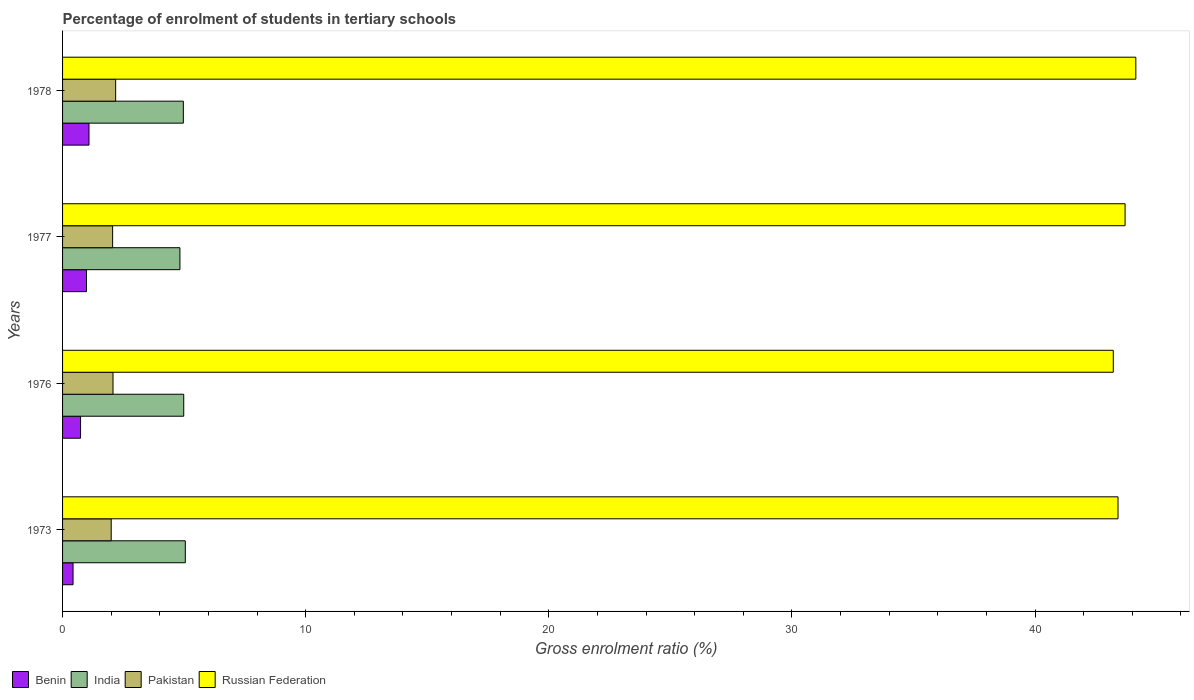How many different coloured bars are there?
Keep it short and to the point. 4. What is the label of the 2nd group of bars from the top?
Your answer should be very brief. 1977. In how many cases, is the number of bars for a given year not equal to the number of legend labels?
Offer a very short reply. 0. What is the percentage of students enrolled in tertiary schools in Russian Federation in 1976?
Give a very brief answer. 43.22. Across all years, what is the maximum percentage of students enrolled in tertiary schools in Benin?
Provide a succinct answer. 1.09. Across all years, what is the minimum percentage of students enrolled in tertiary schools in India?
Offer a very short reply. 4.83. In which year was the percentage of students enrolled in tertiary schools in Russian Federation maximum?
Provide a short and direct response. 1978. What is the total percentage of students enrolled in tertiary schools in India in the graph?
Ensure brevity in your answer.  19.83. What is the difference between the percentage of students enrolled in tertiary schools in Benin in 1973 and that in 1978?
Ensure brevity in your answer.  -0.66. What is the difference between the percentage of students enrolled in tertiary schools in Russian Federation in 1973 and the percentage of students enrolled in tertiary schools in India in 1976?
Provide a succinct answer. 38.43. What is the average percentage of students enrolled in tertiary schools in Pakistan per year?
Provide a short and direct response. 2.08. In the year 1978, what is the difference between the percentage of students enrolled in tertiary schools in Russian Federation and percentage of students enrolled in tertiary schools in Benin?
Keep it short and to the point. 43.06. What is the ratio of the percentage of students enrolled in tertiary schools in India in 1977 to that in 1978?
Provide a succinct answer. 0.97. Is the difference between the percentage of students enrolled in tertiary schools in Russian Federation in 1977 and 1978 greater than the difference between the percentage of students enrolled in tertiary schools in Benin in 1977 and 1978?
Offer a very short reply. No. What is the difference between the highest and the second highest percentage of students enrolled in tertiary schools in Pakistan?
Offer a very short reply. 0.11. What is the difference between the highest and the lowest percentage of students enrolled in tertiary schools in India?
Provide a short and direct response. 0.22. Is the sum of the percentage of students enrolled in tertiary schools in Pakistan in 1973 and 1978 greater than the maximum percentage of students enrolled in tertiary schools in Russian Federation across all years?
Offer a very short reply. No. What does the 2nd bar from the top in 1976 represents?
Offer a very short reply. Pakistan. What does the 1st bar from the bottom in 1973 represents?
Offer a very short reply. Benin. How many bars are there?
Make the answer very short. 16. Are all the bars in the graph horizontal?
Offer a very short reply. Yes. Are the values on the major ticks of X-axis written in scientific E-notation?
Provide a succinct answer. No. How many legend labels are there?
Your response must be concise. 4. What is the title of the graph?
Make the answer very short. Percentage of enrolment of students in tertiary schools. What is the label or title of the Y-axis?
Offer a terse response. Years. What is the Gross enrolment ratio (%) in Benin in 1973?
Provide a succinct answer. 0.43. What is the Gross enrolment ratio (%) in India in 1973?
Make the answer very short. 5.05. What is the Gross enrolment ratio (%) in Pakistan in 1973?
Your answer should be very brief. 2. What is the Gross enrolment ratio (%) of Russian Federation in 1973?
Provide a succinct answer. 43.41. What is the Gross enrolment ratio (%) of Benin in 1976?
Offer a terse response. 0.74. What is the Gross enrolment ratio (%) in India in 1976?
Ensure brevity in your answer.  4.98. What is the Gross enrolment ratio (%) of Pakistan in 1976?
Make the answer very short. 2.08. What is the Gross enrolment ratio (%) in Russian Federation in 1976?
Ensure brevity in your answer.  43.22. What is the Gross enrolment ratio (%) of Benin in 1977?
Offer a very short reply. 0.98. What is the Gross enrolment ratio (%) in India in 1977?
Give a very brief answer. 4.83. What is the Gross enrolment ratio (%) of Pakistan in 1977?
Provide a succinct answer. 2.06. What is the Gross enrolment ratio (%) of Russian Federation in 1977?
Give a very brief answer. 43.7. What is the Gross enrolment ratio (%) of Benin in 1978?
Give a very brief answer. 1.09. What is the Gross enrolment ratio (%) in India in 1978?
Give a very brief answer. 4.97. What is the Gross enrolment ratio (%) in Pakistan in 1978?
Your answer should be very brief. 2.18. What is the Gross enrolment ratio (%) in Russian Federation in 1978?
Offer a terse response. 44.15. Across all years, what is the maximum Gross enrolment ratio (%) of Benin?
Keep it short and to the point. 1.09. Across all years, what is the maximum Gross enrolment ratio (%) in India?
Provide a succinct answer. 5.05. Across all years, what is the maximum Gross enrolment ratio (%) of Pakistan?
Your answer should be very brief. 2.18. Across all years, what is the maximum Gross enrolment ratio (%) in Russian Federation?
Provide a succinct answer. 44.15. Across all years, what is the minimum Gross enrolment ratio (%) of Benin?
Provide a succinct answer. 0.43. Across all years, what is the minimum Gross enrolment ratio (%) of India?
Offer a very short reply. 4.83. Across all years, what is the minimum Gross enrolment ratio (%) in Pakistan?
Make the answer very short. 2. Across all years, what is the minimum Gross enrolment ratio (%) in Russian Federation?
Your answer should be compact. 43.22. What is the total Gross enrolment ratio (%) in Benin in the graph?
Offer a terse response. 3.24. What is the total Gross enrolment ratio (%) of India in the graph?
Ensure brevity in your answer.  19.83. What is the total Gross enrolment ratio (%) of Pakistan in the graph?
Your answer should be very brief. 8.32. What is the total Gross enrolment ratio (%) in Russian Federation in the graph?
Keep it short and to the point. 174.48. What is the difference between the Gross enrolment ratio (%) in Benin in 1973 and that in 1976?
Provide a short and direct response. -0.31. What is the difference between the Gross enrolment ratio (%) in India in 1973 and that in 1976?
Your answer should be very brief. 0.06. What is the difference between the Gross enrolment ratio (%) of Pakistan in 1973 and that in 1976?
Provide a succinct answer. -0.07. What is the difference between the Gross enrolment ratio (%) of Russian Federation in 1973 and that in 1976?
Your answer should be very brief. 0.19. What is the difference between the Gross enrolment ratio (%) of Benin in 1973 and that in 1977?
Your answer should be very brief. -0.55. What is the difference between the Gross enrolment ratio (%) of India in 1973 and that in 1977?
Offer a terse response. 0.22. What is the difference between the Gross enrolment ratio (%) in Pakistan in 1973 and that in 1977?
Your answer should be compact. -0.06. What is the difference between the Gross enrolment ratio (%) in Russian Federation in 1973 and that in 1977?
Keep it short and to the point. -0.29. What is the difference between the Gross enrolment ratio (%) of Benin in 1973 and that in 1978?
Your answer should be very brief. -0.66. What is the difference between the Gross enrolment ratio (%) in India in 1973 and that in 1978?
Provide a short and direct response. 0.08. What is the difference between the Gross enrolment ratio (%) in Pakistan in 1973 and that in 1978?
Offer a terse response. -0.18. What is the difference between the Gross enrolment ratio (%) of Russian Federation in 1973 and that in 1978?
Offer a very short reply. -0.73. What is the difference between the Gross enrolment ratio (%) in Benin in 1976 and that in 1977?
Make the answer very short. -0.24. What is the difference between the Gross enrolment ratio (%) in India in 1976 and that in 1977?
Your answer should be compact. 0.16. What is the difference between the Gross enrolment ratio (%) in Pakistan in 1976 and that in 1977?
Give a very brief answer. 0.02. What is the difference between the Gross enrolment ratio (%) of Russian Federation in 1976 and that in 1977?
Your answer should be compact. -0.49. What is the difference between the Gross enrolment ratio (%) in Benin in 1976 and that in 1978?
Offer a very short reply. -0.35. What is the difference between the Gross enrolment ratio (%) of India in 1976 and that in 1978?
Provide a succinct answer. 0.02. What is the difference between the Gross enrolment ratio (%) of Pakistan in 1976 and that in 1978?
Give a very brief answer. -0.11. What is the difference between the Gross enrolment ratio (%) in Russian Federation in 1976 and that in 1978?
Give a very brief answer. -0.93. What is the difference between the Gross enrolment ratio (%) of Benin in 1977 and that in 1978?
Provide a short and direct response. -0.1. What is the difference between the Gross enrolment ratio (%) in India in 1977 and that in 1978?
Your answer should be very brief. -0.14. What is the difference between the Gross enrolment ratio (%) in Pakistan in 1977 and that in 1978?
Your answer should be compact. -0.12. What is the difference between the Gross enrolment ratio (%) in Russian Federation in 1977 and that in 1978?
Provide a short and direct response. -0.44. What is the difference between the Gross enrolment ratio (%) in Benin in 1973 and the Gross enrolment ratio (%) in India in 1976?
Your answer should be very brief. -4.55. What is the difference between the Gross enrolment ratio (%) of Benin in 1973 and the Gross enrolment ratio (%) of Pakistan in 1976?
Your answer should be compact. -1.64. What is the difference between the Gross enrolment ratio (%) in Benin in 1973 and the Gross enrolment ratio (%) in Russian Federation in 1976?
Offer a terse response. -42.79. What is the difference between the Gross enrolment ratio (%) in India in 1973 and the Gross enrolment ratio (%) in Pakistan in 1976?
Provide a succinct answer. 2.97. What is the difference between the Gross enrolment ratio (%) in India in 1973 and the Gross enrolment ratio (%) in Russian Federation in 1976?
Your answer should be compact. -38.17. What is the difference between the Gross enrolment ratio (%) in Pakistan in 1973 and the Gross enrolment ratio (%) in Russian Federation in 1976?
Your answer should be compact. -41.22. What is the difference between the Gross enrolment ratio (%) in Benin in 1973 and the Gross enrolment ratio (%) in India in 1977?
Offer a terse response. -4.4. What is the difference between the Gross enrolment ratio (%) in Benin in 1973 and the Gross enrolment ratio (%) in Pakistan in 1977?
Your answer should be compact. -1.63. What is the difference between the Gross enrolment ratio (%) of Benin in 1973 and the Gross enrolment ratio (%) of Russian Federation in 1977?
Offer a terse response. -43.27. What is the difference between the Gross enrolment ratio (%) of India in 1973 and the Gross enrolment ratio (%) of Pakistan in 1977?
Provide a short and direct response. 2.99. What is the difference between the Gross enrolment ratio (%) of India in 1973 and the Gross enrolment ratio (%) of Russian Federation in 1977?
Provide a succinct answer. -38.65. What is the difference between the Gross enrolment ratio (%) of Pakistan in 1973 and the Gross enrolment ratio (%) of Russian Federation in 1977?
Keep it short and to the point. -41.7. What is the difference between the Gross enrolment ratio (%) of Benin in 1973 and the Gross enrolment ratio (%) of India in 1978?
Your response must be concise. -4.54. What is the difference between the Gross enrolment ratio (%) in Benin in 1973 and the Gross enrolment ratio (%) in Pakistan in 1978?
Keep it short and to the point. -1.75. What is the difference between the Gross enrolment ratio (%) of Benin in 1973 and the Gross enrolment ratio (%) of Russian Federation in 1978?
Make the answer very short. -43.71. What is the difference between the Gross enrolment ratio (%) in India in 1973 and the Gross enrolment ratio (%) in Pakistan in 1978?
Your answer should be very brief. 2.87. What is the difference between the Gross enrolment ratio (%) in India in 1973 and the Gross enrolment ratio (%) in Russian Federation in 1978?
Give a very brief answer. -39.1. What is the difference between the Gross enrolment ratio (%) in Pakistan in 1973 and the Gross enrolment ratio (%) in Russian Federation in 1978?
Offer a terse response. -42.14. What is the difference between the Gross enrolment ratio (%) of Benin in 1976 and the Gross enrolment ratio (%) of India in 1977?
Give a very brief answer. -4.09. What is the difference between the Gross enrolment ratio (%) of Benin in 1976 and the Gross enrolment ratio (%) of Pakistan in 1977?
Give a very brief answer. -1.32. What is the difference between the Gross enrolment ratio (%) in Benin in 1976 and the Gross enrolment ratio (%) in Russian Federation in 1977?
Give a very brief answer. -42.96. What is the difference between the Gross enrolment ratio (%) of India in 1976 and the Gross enrolment ratio (%) of Pakistan in 1977?
Give a very brief answer. 2.93. What is the difference between the Gross enrolment ratio (%) of India in 1976 and the Gross enrolment ratio (%) of Russian Federation in 1977?
Your answer should be compact. -38.72. What is the difference between the Gross enrolment ratio (%) of Pakistan in 1976 and the Gross enrolment ratio (%) of Russian Federation in 1977?
Make the answer very short. -41.63. What is the difference between the Gross enrolment ratio (%) of Benin in 1976 and the Gross enrolment ratio (%) of India in 1978?
Your response must be concise. -4.23. What is the difference between the Gross enrolment ratio (%) of Benin in 1976 and the Gross enrolment ratio (%) of Pakistan in 1978?
Provide a short and direct response. -1.44. What is the difference between the Gross enrolment ratio (%) in Benin in 1976 and the Gross enrolment ratio (%) in Russian Federation in 1978?
Ensure brevity in your answer.  -43.41. What is the difference between the Gross enrolment ratio (%) in India in 1976 and the Gross enrolment ratio (%) in Pakistan in 1978?
Make the answer very short. 2.8. What is the difference between the Gross enrolment ratio (%) in India in 1976 and the Gross enrolment ratio (%) in Russian Federation in 1978?
Your answer should be very brief. -39.16. What is the difference between the Gross enrolment ratio (%) of Pakistan in 1976 and the Gross enrolment ratio (%) of Russian Federation in 1978?
Your answer should be very brief. -42.07. What is the difference between the Gross enrolment ratio (%) in Benin in 1977 and the Gross enrolment ratio (%) in India in 1978?
Offer a very short reply. -3.98. What is the difference between the Gross enrolment ratio (%) of Benin in 1977 and the Gross enrolment ratio (%) of Pakistan in 1978?
Ensure brevity in your answer.  -1.2. What is the difference between the Gross enrolment ratio (%) in Benin in 1977 and the Gross enrolment ratio (%) in Russian Federation in 1978?
Keep it short and to the point. -43.16. What is the difference between the Gross enrolment ratio (%) in India in 1977 and the Gross enrolment ratio (%) in Pakistan in 1978?
Give a very brief answer. 2.64. What is the difference between the Gross enrolment ratio (%) in India in 1977 and the Gross enrolment ratio (%) in Russian Federation in 1978?
Provide a short and direct response. -39.32. What is the difference between the Gross enrolment ratio (%) in Pakistan in 1977 and the Gross enrolment ratio (%) in Russian Federation in 1978?
Your answer should be compact. -42.09. What is the average Gross enrolment ratio (%) of Benin per year?
Offer a very short reply. 0.81. What is the average Gross enrolment ratio (%) in India per year?
Your answer should be compact. 4.96. What is the average Gross enrolment ratio (%) in Pakistan per year?
Your response must be concise. 2.08. What is the average Gross enrolment ratio (%) in Russian Federation per year?
Ensure brevity in your answer.  43.62. In the year 1973, what is the difference between the Gross enrolment ratio (%) of Benin and Gross enrolment ratio (%) of India?
Your answer should be very brief. -4.62. In the year 1973, what is the difference between the Gross enrolment ratio (%) in Benin and Gross enrolment ratio (%) in Pakistan?
Provide a short and direct response. -1.57. In the year 1973, what is the difference between the Gross enrolment ratio (%) in Benin and Gross enrolment ratio (%) in Russian Federation?
Your answer should be very brief. -42.98. In the year 1973, what is the difference between the Gross enrolment ratio (%) in India and Gross enrolment ratio (%) in Pakistan?
Keep it short and to the point. 3.05. In the year 1973, what is the difference between the Gross enrolment ratio (%) in India and Gross enrolment ratio (%) in Russian Federation?
Provide a short and direct response. -38.36. In the year 1973, what is the difference between the Gross enrolment ratio (%) in Pakistan and Gross enrolment ratio (%) in Russian Federation?
Ensure brevity in your answer.  -41.41. In the year 1976, what is the difference between the Gross enrolment ratio (%) in Benin and Gross enrolment ratio (%) in India?
Offer a terse response. -4.24. In the year 1976, what is the difference between the Gross enrolment ratio (%) in Benin and Gross enrolment ratio (%) in Pakistan?
Your answer should be very brief. -1.34. In the year 1976, what is the difference between the Gross enrolment ratio (%) of Benin and Gross enrolment ratio (%) of Russian Federation?
Your response must be concise. -42.48. In the year 1976, what is the difference between the Gross enrolment ratio (%) in India and Gross enrolment ratio (%) in Pakistan?
Your answer should be very brief. 2.91. In the year 1976, what is the difference between the Gross enrolment ratio (%) of India and Gross enrolment ratio (%) of Russian Federation?
Your answer should be very brief. -38.23. In the year 1976, what is the difference between the Gross enrolment ratio (%) of Pakistan and Gross enrolment ratio (%) of Russian Federation?
Give a very brief answer. -41.14. In the year 1977, what is the difference between the Gross enrolment ratio (%) in Benin and Gross enrolment ratio (%) in India?
Give a very brief answer. -3.84. In the year 1977, what is the difference between the Gross enrolment ratio (%) in Benin and Gross enrolment ratio (%) in Pakistan?
Your answer should be compact. -1.08. In the year 1977, what is the difference between the Gross enrolment ratio (%) in Benin and Gross enrolment ratio (%) in Russian Federation?
Provide a short and direct response. -42.72. In the year 1977, what is the difference between the Gross enrolment ratio (%) of India and Gross enrolment ratio (%) of Pakistan?
Your answer should be compact. 2.77. In the year 1977, what is the difference between the Gross enrolment ratio (%) in India and Gross enrolment ratio (%) in Russian Federation?
Provide a succinct answer. -38.88. In the year 1977, what is the difference between the Gross enrolment ratio (%) in Pakistan and Gross enrolment ratio (%) in Russian Federation?
Your response must be concise. -41.64. In the year 1978, what is the difference between the Gross enrolment ratio (%) in Benin and Gross enrolment ratio (%) in India?
Offer a terse response. -3.88. In the year 1978, what is the difference between the Gross enrolment ratio (%) of Benin and Gross enrolment ratio (%) of Pakistan?
Provide a succinct answer. -1.1. In the year 1978, what is the difference between the Gross enrolment ratio (%) in Benin and Gross enrolment ratio (%) in Russian Federation?
Offer a terse response. -43.06. In the year 1978, what is the difference between the Gross enrolment ratio (%) of India and Gross enrolment ratio (%) of Pakistan?
Make the answer very short. 2.78. In the year 1978, what is the difference between the Gross enrolment ratio (%) of India and Gross enrolment ratio (%) of Russian Federation?
Keep it short and to the point. -39.18. In the year 1978, what is the difference between the Gross enrolment ratio (%) in Pakistan and Gross enrolment ratio (%) in Russian Federation?
Keep it short and to the point. -41.96. What is the ratio of the Gross enrolment ratio (%) in Benin in 1973 to that in 1976?
Offer a very short reply. 0.58. What is the ratio of the Gross enrolment ratio (%) of India in 1973 to that in 1976?
Give a very brief answer. 1.01. What is the ratio of the Gross enrolment ratio (%) in Benin in 1973 to that in 1977?
Your answer should be very brief. 0.44. What is the ratio of the Gross enrolment ratio (%) in India in 1973 to that in 1977?
Ensure brevity in your answer.  1.05. What is the ratio of the Gross enrolment ratio (%) in Pakistan in 1973 to that in 1977?
Provide a succinct answer. 0.97. What is the ratio of the Gross enrolment ratio (%) in Benin in 1973 to that in 1978?
Your answer should be compact. 0.4. What is the ratio of the Gross enrolment ratio (%) in India in 1973 to that in 1978?
Your answer should be very brief. 1.02. What is the ratio of the Gross enrolment ratio (%) of Pakistan in 1973 to that in 1978?
Provide a short and direct response. 0.92. What is the ratio of the Gross enrolment ratio (%) in Russian Federation in 1973 to that in 1978?
Provide a succinct answer. 0.98. What is the ratio of the Gross enrolment ratio (%) of Benin in 1976 to that in 1977?
Your answer should be very brief. 0.75. What is the ratio of the Gross enrolment ratio (%) of India in 1976 to that in 1977?
Provide a short and direct response. 1.03. What is the ratio of the Gross enrolment ratio (%) in Pakistan in 1976 to that in 1977?
Ensure brevity in your answer.  1.01. What is the ratio of the Gross enrolment ratio (%) of Russian Federation in 1976 to that in 1977?
Offer a terse response. 0.99. What is the ratio of the Gross enrolment ratio (%) in Benin in 1976 to that in 1978?
Offer a terse response. 0.68. What is the ratio of the Gross enrolment ratio (%) of India in 1976 to that in 1978?
Your response must be concise. 1. What is the ratio of the Gross enrolment ratio (%) of Pakistan in 1976 to that in 1978?
Make the answer very short. 0.95. What is the ratio of the Gross enrolment ratio (%) of Russian Federation in 1976 to that in 1978?
Keep it short and to the point. 0.98. What is the ratio of the Gross enrolment ratio (%) of Benin in 1977 to that in 1978?
Give a very brief answer. 0.9. What is the ratio of the Gross enrolment ratio (%) in India in 1977 to that in 1978?
Your response must be concise. 0.97. What is the ratio of the Gross enrolment ratio (%) in Pakistan in 1977 to that in 1978?
Provide a short and direct response. 0.94. What is the ratio of the Gross enrolment ratio (%) in Russian Federation in 1977 to that in 1978?
Make the answer very short. 0.99. What is the difference between the highest and the second highest Gross enrolment ratio (%) of Benin?
Your response must be concise. 0.1. What is the difference between the highest and the second highest Gross enrolment ratio (%) in India?
Your response must be concise. 0.06. What is the difference between the highest and the second highest Gross enrolment ratio (%) of Pakistan?
Your answer should be compact. 0.11. What is the difference between the highest and the second highest Gross enrolment ratio (%) in Russian Federation?
Your response must be concise. 0.44. What is the difference between the highest and the lowest Gross enrolment ratio (%) of Benin?
Provide a succinct answer. 0.66. What is the difference between the highest and the lowest Gross enrolment ratio (%) of India?
Provide a succinct answer. 0.22. What is the difference between the highest and the lowest Gross enrolment ratio (%) of Pakistan?
Make the answer very short. 0.18. What is the difference between the highest and the lowest Gross enrolment ratio (%) in Russian Federation?
Provide a succinct answer. 0.93. 